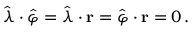Convert formula to latex. <formula><loc_0><loc_0><loc_500><loc_500>{ \hat { \lambda } } \cdot { \hat { \varphi } } = { \hat { \lambda } } \cdot r = { \hat { \varphi } } \cdot r = 0 \, .</formula> 